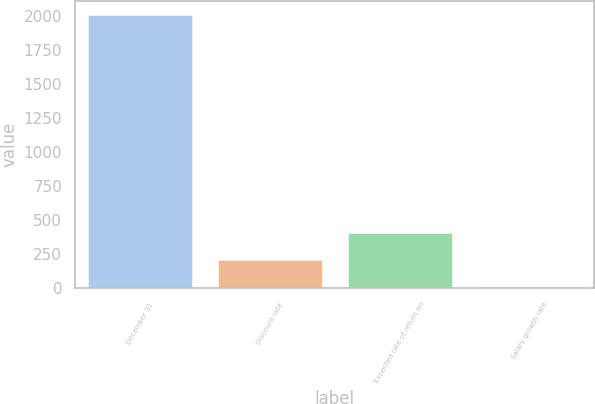Convert chart to OTSL. <chart><loc_0><loc_0><loc_500><loc_500><bar_chart><fcel>December 31<fcel>Discount rate<fcel>Expected rate of return on<fcel>Salary growth rate<nl><fcel>2009<fcel>204.77<fcel>405.24<fcel>4.3<nl></chart> 